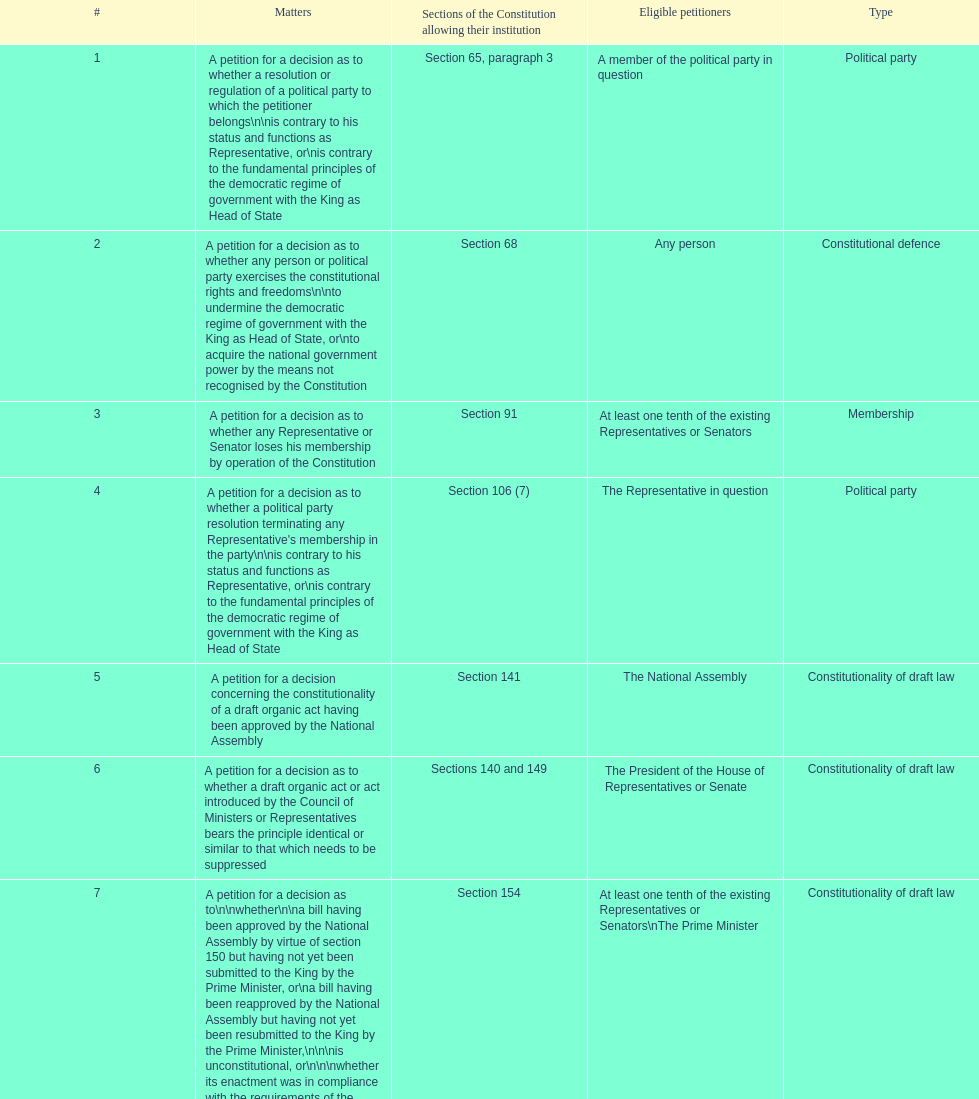Can you parse all the data within this table? {'header': ['#', 'Matters', 'Sections of the Constitution allowing their institution', 'Eligible petitioners', 'Type'], 'rows': [['1', 'A petition for a decision as to whether a resolution or regulation of a political party to which the petitioner belongs\\n\\nis contrary to his status and functions as Representative, or\\nis contrary to the fundamental principles of the democratic regime of government with the King as Head of State', 'Section 65, paragraph 3', 'A member of the political party in question', 'Political party'], ['2', 'A petition for a decision as to whether any person or political party exercises the constitutional rights and freedoms\\n\\nto undermine the democratic regime of government with the King as Head of State, or\\nto acquire the national government power by the means not recognised by the Constitution', 'Section 68', 'Any person', 'Constitutional defence'], ['3', 'A petition for a decision as to whether any Representative or Senator loses his membership by operation of the Constitution', 'Section 91', 'At least one tenth of the existing Representatives or Senators', 'Membership'], ['4', "A petition for a decision as to whether a political party resolution terminating any Representative's membership in the party\\n\\nis contrary to his status and functions as Representative, or\\nis contrary to the fundamental principles of the democratic regime of government with the King as Head of State", 'Section 106 (7)', 'The Representative in question', 'Political party'], ['5', 'A petition for a decision concerning the constitutionality of a draft organic act having been approved by the National Assembly', 'Section 141', 'The National Assembly', 'Constitutionality of draft law'], ['6', 'A petition for a decision as to whether a draft organic act or act introduced by the Council of Ministers or Representatives bears the principle identical or similar to that which needs to be suppressed', 'Sections 140 and 149', 'The President of the House of Representatives or Senate', 'Constitutionality of draft law'], ['7', 'A petition for a decision as to\\n\\nwhether\\n\\na bill having been approved by the National Assembly by virtue of section 150 but having not yet been submitted to the King by the Prime Minister, or\\na bill having been reapproved by the National Assembly but having not yet been resubmitted to the King by the Prime Minister,\\n\\n\\nis unconstitutional, or\\n\\n\\nwhether its enactment was in compliance with the requirements of the Constitution', 'Section 154', 'At least one tenth of the existing Representatives or Senators\\nThe Prime Minister', 'Constitutionality of draft law'], ['8', 'A petition for a decision as to\\n\\nwhether the draft rules of order of the House of Representatives, the draft rules of order of the Senate, or the draft rules of order of the National Assembly, which have been approved by the House of Representatives, Senate or National Assembly but have not yet been published in the Government Gazette, are unconstitutional, or\\nwhether their enactment was in compliance with the requirements of the Constitution', 'Section 155', 'At least one tenth of the existing Representatives or Senators\\nThe Prime Minister', 'Constitutionality of draft law'], ['9', 'A petition for a decision as to whether any motion, motion amendment or action introduced during the House of Representatives, Senate or committee proceedings for consideration of a draft bill on annual expenditure budget, additional expenditure budget or expenditure budget transfer, would allow a Representative, Senator or committee member to directly or indirectly be involved in the disbursement of such budget', 'Section 168, paragraph 7', 'At least one tenth of the existing Representatives or Senators', 'Others'], ['10', 'A petition for a decision as to whether any Minister individually loses his ministership', 'Section 182', 'At least one tenth of the existing Representatives or Senators\\nThe Election Commission', 'Membership'], ['11', 'A petition for a decision as to whether an emergency decree is enacted against section 184, paragraph 1 or 2, of the Constitution', 'Section 185', 'At least one fifth of the existing Representatives or Senators', 'Constitutionality of law'], ['12', 'A petition for a decision as to whether any "written agreement" to be concluded by the Executive Branch requires prior parliamentary approval because\\n\\nit contains a provision which would bring about a change in the Thai territory or the extraterritorial areas over which Thailand is competent to exercise sovereignty or jurisdiction by virtue of a written agreement or international law,\\nits execution requires the enactment of an act,\\nit would extensively affect national economic or social security, or\\nit would considerably bind national trade, investment or budget', 'Section 190', 'At least one tenth of the existing Representatives or Senators', 'Authority'], ['13', 'A petition for a decision as to whether a legal provision to be applied to any case by a court of justice, administrative court or military court is unconstitutional', 'Section 211', 'A party to such case', 'Constitutionality of law'], ['14', 'A petition for a decision as to the constitutionality of a legal provision', 'Section 212', 'Any person whose constitutionally recognised right or freedom has been violated', 'Constitutionality of law'], ['15', 'A petition for a decision as to a conflict of authority between the National Assembly, the Council of Ministers, or two or more constitutional organs other than the courts of justice, administrative courts or military courts', 'Section 214', 'The President of the National Assembly\\nThe Prime Minister\\nThe organs in question', 'Authority'], ['16', 'A petition for a decision as to whether any Election Commissioner lacks a qualification, is attacked by a disqualification or has committed a prohibited act', 'Section 233', 'At least one tenth of the existing Representatives or Senators', 'Membership'], ['17', 'A petition for\\n\\ndissolution of a political party deemed to have attempted to acquire the national government power by the means not recognised by the Constitution, and\\ndisfranchisement of its leader and executive members', 'Section 237 in conjunction with section 68', 'Any person', 'Political party'], ['18', 'A petition for a decision as to the constitutionality of any legal provision', 'Section 245 (1)', 'Ombudsmen', 'Constitutionality of law'], ['19', 'A petition for a decision as to the constitutionality of any legal provision on grounds of human rights', 'Section 257, paragraph 1 (2)', 'The National Human Rights Commission', 'Constitutionality of law'], ['20', 'Other matters permitted by legal provisions', '', '', 'Others']]} How many subjects demand at least one-tenth of the existing representatives or senators? 7. 